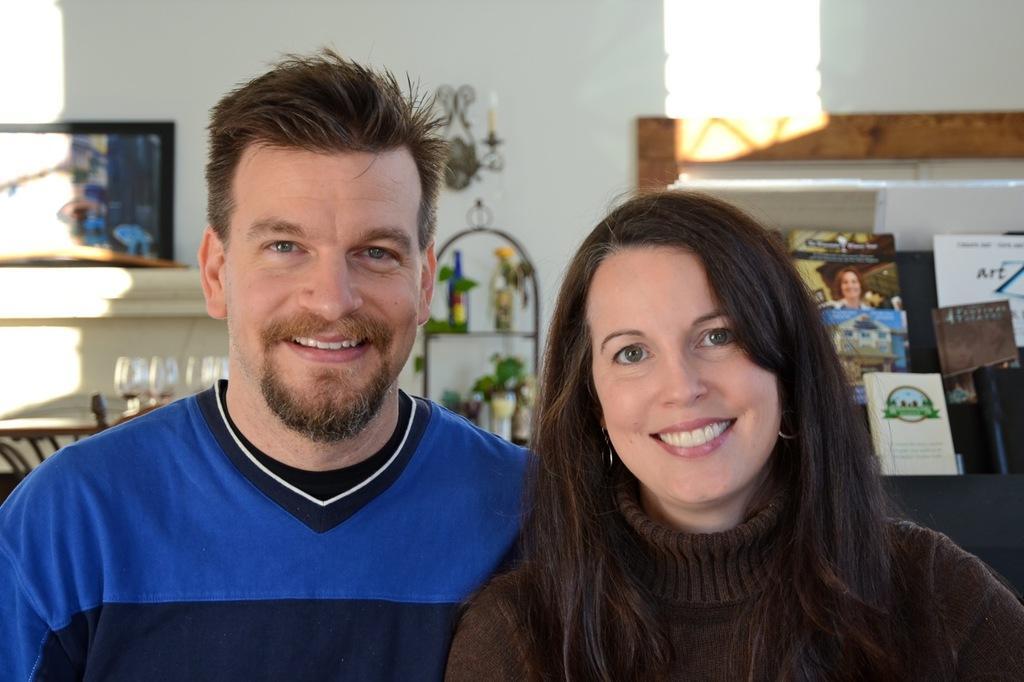Could you give a brief overview of what you see in this image? In this picture there is a man who is wearing blue t-shirt, beside him there is a woman who is wearing t-shirt and earrings. Both of them are smiling. At the back we can see wine bottles, plants, books and other objects on the table and racks. On the left there is a painting on the wall. 